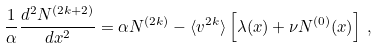Convert formula to latex. <formula><loc_0><loc_0><loc_500><loc_500>\frac { 1 } { \alpha } \frac { d ^ { 2 } N ^ { ( 2 k + 2 ) } } { d x ^ { 2 } } = \alpha N ^ { ( 2 k ) } - \langle v ^ { 2 k } \rangle \left [ \lambda ( x ) + \nu N ^ { ( 0 ) } ( x ) \right ] \, , \\</formula> 